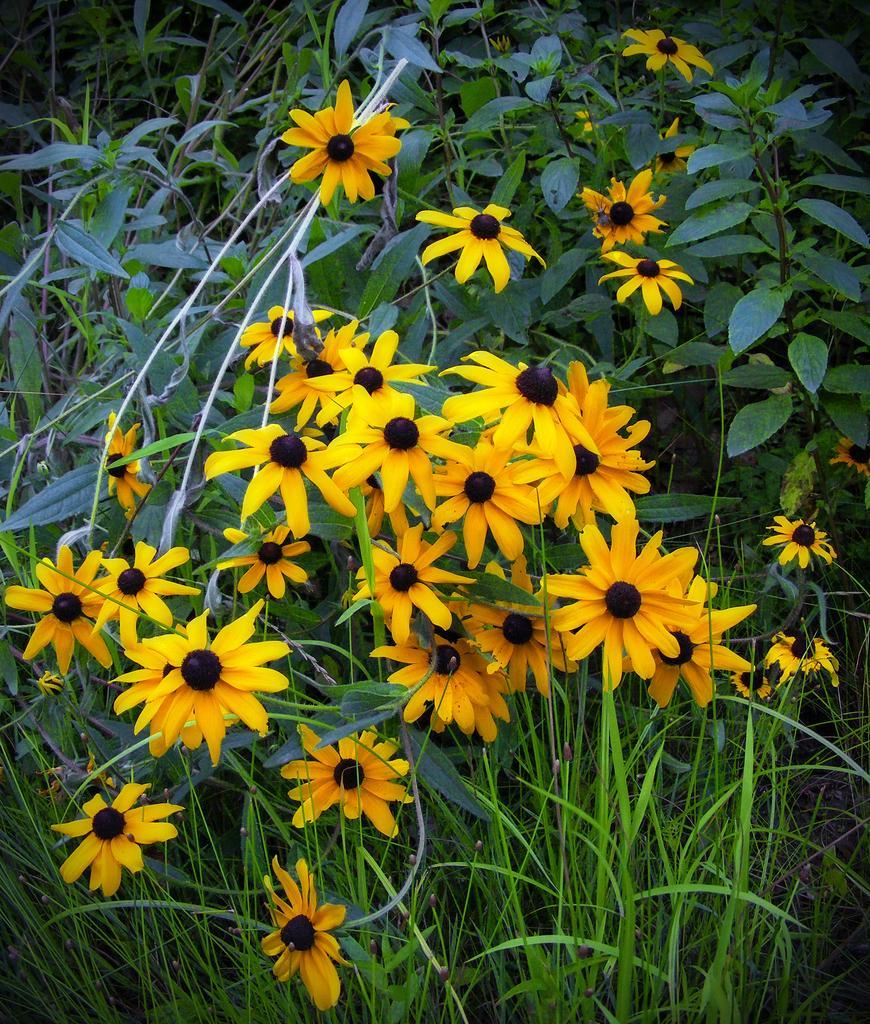Can you describe this image briefly? In this image, I can see the plants with leaves and flowers. These flowers are yellow in color. 